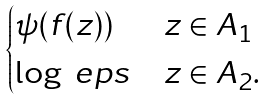<formula> <loc_0><loc_0><loc_500><loc_500>\begin{cases} \psi ( f ( z ) ) & z \in A _ { 1 } \\ \log \ e p s & z \in A _ { 2 } . \end{cases}</formula> 